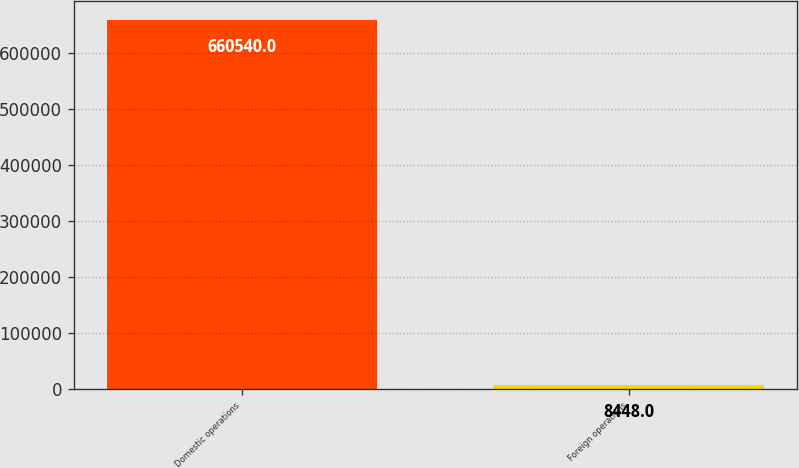<chart> <loc_0><loc_0><loc_500><loc_500><bar_chart><fcel>Domestic operations<fcel>Foreign operations<nl><fcel>660540<fcel>8448<nl></chart> 